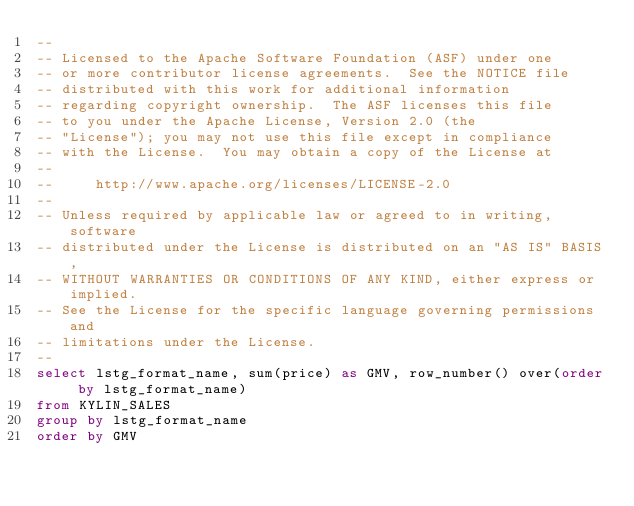<code> <loc_0><loc_0><loc_500><loc_500><_SQL_>--
-- Licensed to the Apache Software Foundation (ASF) under one
-- or more contributor license agreements.  See the NOTICE file
-- distributed with this work for additional information
-- regarding copyright ownership.  The ASF licenses this file
-- to you under the Apache License, Version 2.0 (the
-- "License"); you may not use this file except in compliance
-- with the License.  You may obtain a copy of the License at
--
--     http://www.apache.org/licenses/LICENSE-2.0
--
-- Unless required by applicable law or agreed to in writing, software
-- distributed under the License is distributed on an "AS IS" BASIS,
-- WITHOUT WARRANTIES OR CONDITIONS OF ANY KIND, either express or implied.
-- See the License for the specific language governing permissions and
-- limitations under the License.
--
select lstg_format_name, sum(price) as GMV, row_number() over(order by lstg_format_name)
from KYLIN_SALES
group by lstg_format_name
order by GMV</code> 